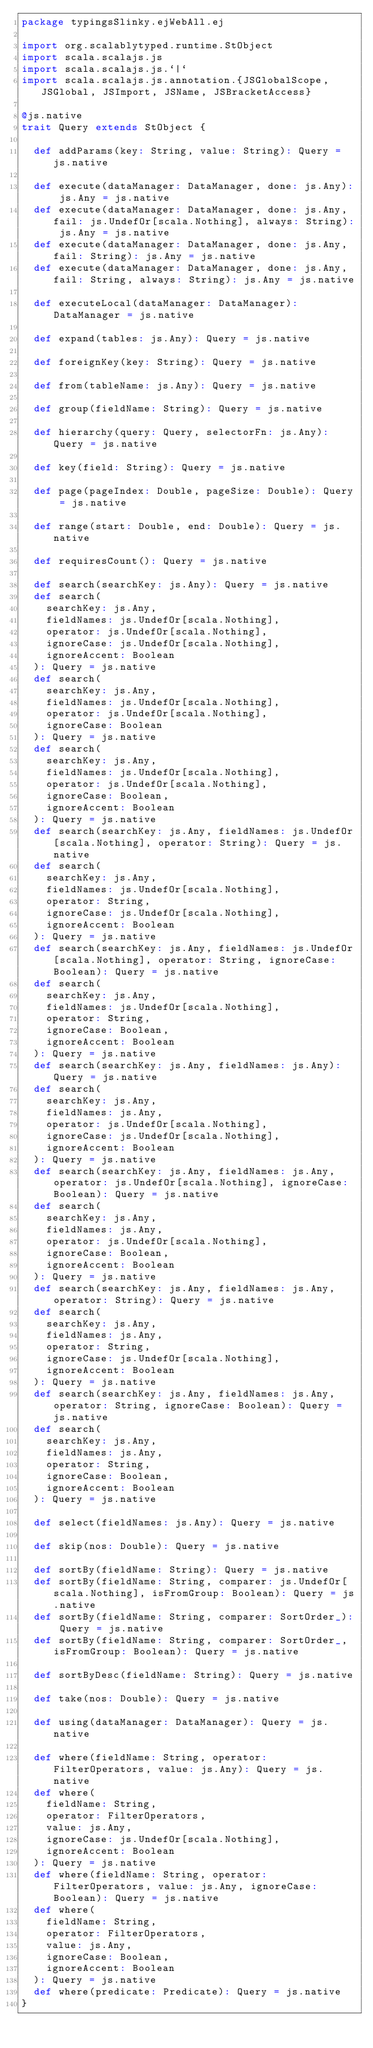Convert code to text. <code><loc_0><loc_0><loc_500><loc_500><_Scala_>package typingsSlinky.ejWebAll.ej

import org.scalablytyped.runtime.StObject
import scala.scalajs.js
import scala.scalajs.js.`|`
import scala.scalajs.js.annotation.{JSGlobalScope, JSGlobal, JSImport, JSName, JSBracketAccess}

@js.native
trait Query extends StObject {
  
  def addParams(key: String, value: String): Query = js.native
  
  def execute(dataManager: DataManager, done: js.Any): js.Any = js.native
  def execute(dataManager: DataManager, done: js.Any, fail: js.UndefOr[scala.Nothing], always: String): js.Any = js.native
  def execute(dataManager: DataManager, done: js.Any, fail: String): js.Any = js.native
  def execute(dataManager: DataManager, done: js.Any, fail: String, always: String): js.Any = js.native
  
  def executeLocal(dataManager: DataManager): DataManager = js.native
  
  def expand(tables: js.Any): Query = js.native
  
  def foreignKey(key: String): Query = js.native
  
  def from(tableName: js.Any): Query = js.native
  
  def group(fieldName: String): Query = js.native
  
  def hierarchy(query: Query, selectorFn: js.Any): Query = js.native
  
  def key(field: String): Query = js.native
  
  def page(pageIndex: Double, pageSize: Double): Query = js.native
  
  def range(start: Double, end: Double): Query = js.native
  
  def requiresCount(): Query = js.native
  
  def search(searchKey: js.Any): Query = js.native
  def search(
    searchKey: js.Any,
    fieldNames: js.UndefOr[scala.Nothing],
    operator: js.UndefOr[scala.Nothing],
    ignoreCase: js.UndefOr[scala.Nothing],
    ignoreAccent: Boolean
  ): Query = js.native
  def search(
    searchKey: js.Any,
    fieldNames: js.UndefOr[scala.Nothing],
    operator: js.UndefOr[scala.Nothing],
    ignoreCase: Boolean
  ): Query = js.native
  def search(
    searchKey: js.Any,
    fieldNames: js.UndefOr[scala.Nothing],
    operator: js.UndefOr[scala.Nothing],
    ignoreCase: Boolean,
    ignoreAccent: Boolean
  ): Query = js.native
  def search(searchKey: js.Any, fieldNames: js.UndefOr[scala.Nothing], operator: String): Query = js.native
  def search(
    searchKey: js.Any,
    fieldNames: js.UndefOr[scala.Nothing],
    operator: String,
    ignoreCase: js.UndefOr[scala.Nothing],
    ignoreAccent: Boolean
  ): Query = js.native
  def search(searchKey: js.Any, fieldNames: js.UndefOr[scala.Nothing], operator: String, ignoreCase: Boolean): Query = js.native
  def search(
    searchKey: js.Any,
    fieldNames: js.UndefOr[scala.Nothing],
    operator: String,
    ignoreCase: Boolean,
    ignoreAccent: Boolean
  ): Query = js.native
  def search(searchKey: js.Any, fieldNames: js.Any): Query = js.native
  def search(
    searchKey: js.Any,
    fieldNames: js.Any,
    operator: js.UndefOr[scala.Nothing],
    ignoreCase: js.UndefOr[scala.Nothing],
    ignoreAccent: Boolean
  ): Query = js.native
  def search(searchKey: js.Any, fieldNames: js.Any, operator: js.UndefOr[scala.Nothing], ignoreCase: Boolean): Query = js.native
  def search(
    searchKey: js.Any,
    fieldNames: js.Any,
    operator: js.UndefOr[scala.Nothing],
    ignoreCase: Boolean,
    ignoreAccent: Boolean
  ): Query = js.native
  def search(searchKey: js.Any, fieldNames: js.Any, operator: String): Query = js.native
  def search(
    searchKey: js.Any,
    fieldNames: js.Any,
    operator: String,
    ignoreCase: js.UndefOr[scala.Nothing],
    ignoreAccent: Boolean
  ): Query = js.native
  def search(searchKey: js.Any, fieldNames: js.Any, operator: String, ignoreCase: Boolean): Query = js.native
  def search(
    searchKey: js.Any,
    fieldNames: js.Any,
    operator: String,
    ignoreCase: Boolean,
    ignoreAccent: Boolean
  ): Query = js.native
  
  def select(fieldNames: js.Any): Query = js.native
  
  def skip(nos: Double): Query = js.native
  
  def sortBy(fieldName: String): Query = js.native
  def sortBy(fieldName: String, comparer: js.UndefOr[scala.Nothing], isFromGroup: Boolean): Query = js.native
  def sortBy(fieldName: String, comparer: SortOrder_): Query = js.native
  def sortBy(fieldName: String, comparer: SortOrder_, isFromGroup: Boolean): Query = js.native
  
  def sortByDesc(fieldName: String): Query = js.native
  
  def take(nos: Double): Query = js.native
  
  def using(dataManager: DataManager): Query = js.native
  
  def where(fieldName: String, operator: FilterOperators, value: js.Any): Query = js.native
  def where(
    fieldName: String,
    operator: FilterOperators,
    value: js.Any,
    ignoreCase: js.UndefOr[scala.Nothing],
    ignoreAccent: Boolean
  ): Query = js.native
  def where(fieldName: String, operator: FilterOperators, value: js.Any, ignoreCase: Boolean): Query = js.native
  def where(
    fieldName: String,
    operator: FilterOperators,
    value: js.Any,
    ignoreCase: Boolean,
    ignoreAccent: Boolean
  ): Query = js.native
  def where(predicate: Predicate): Query = js.native
}
</code> 